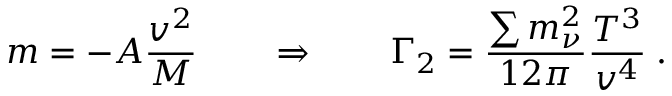Convert formula to latex. <formula><loc_0><loc_0><loc_500><loc_500>m = - A \frac { v ^ { 2 } } { M } \quad \Rightarrow \quad \Gamma _ { 2 } = \frac { \sum m _ { \nu } ^ { 2 } } { 1 2 \pi } \frac { T ^ { 3 } } { v ^ { 4 } } \, .</formula> 